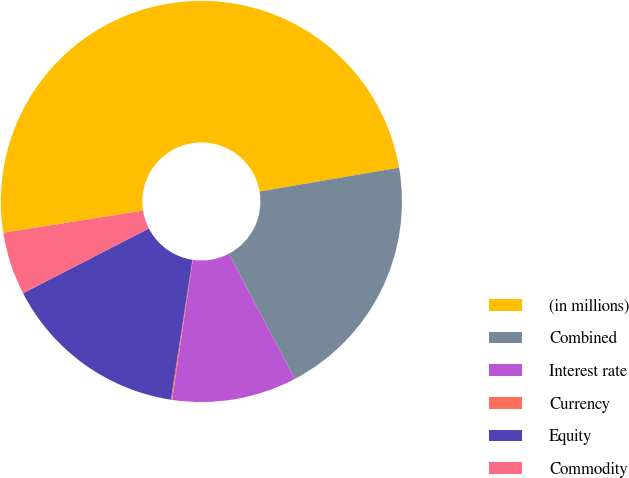Convert chart. <chart><loc_0><loc_0><loc_500><loc_500><pie_chart><fcel>(in millions)<fcel>Combined<fcel>Interest rate<fcel>Currency<fcel>Equity<fcel>Commodity<nl><fcel>49.8%<fcel>19.98%<fcel>10.04%<fcel>0.1%<fcel>15.01%<fcel>5.07%<nl></chart> 